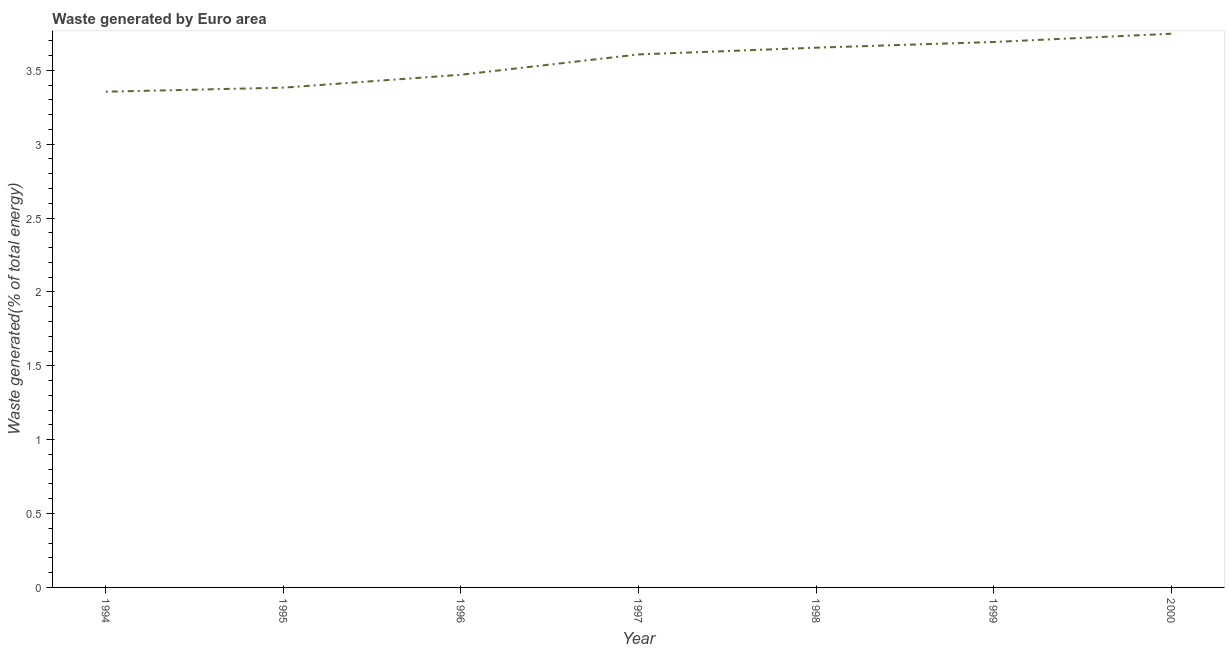What is the amount of waste generated in 2000?
Offer a very short reply. 3.75. Across all years, what is the maximum amount of waste generated?
Your answer should be compact. 3.75. Across all years, what is the minimum amount of waste generated?
Provide a succinct answer. 3.35. What is the sum of the amount of waste generated?
Give a very brief answer. 24.91. What is the difference between the amount of waste generated in 1994 and 1997?
Give a very brief answer. -0.25. What is the average amount of waste generated per year?
Your answer should be very brief. 3.56. What is the median amount of waste generated?
Your response must be concise. 3.61. What is the ratio of the amount of waste generated in 1994 to that in 1997?
Your response must be concise. 0.93. Is the amount of waste generated in 1994 less than that in 1998?
Provide a succinct answer. Yes. Is the difference between the amount of waste generated in 1995 and 2000 greater than the difference between any two years?
Your answer should be very brief. No. What is the difference between the highest and the second highest amount of waste generated?
Provide a short and direct response. 0.06. Is the sum of the amount of waste generated in 1994 and 1995 greater than the maximum amount of waste generated across all years?
Make the answer very short. Yes. What is the difference between the highest and the lowest amount of waste generated?
Offer a terse response. 0.39. How many years are there in the graph?
Give a very brief answer. 7. What is the difference between two consecutive major ticks on the Y-axis?
Ensure brevity in your answer.  0.5. What is the title of the graph?
Offer a very short reply. Waste generated by Euro area. What is the label or title of the Y-axis?
Offer a very short reply. Waste generated(% of total energy). What is the Waste generated(% of total energy) of 1994?
Your answer should be compact. 3.35. What is the Waste generated(% of total energy) in 1995?
Provide a succinct answer. 3.38. What is the Waste generated(% of total energy) in 1996?
Offer a terse response. 3.47. What is the Waste generated(% of total energy) of 1997?
Give a very brief answer. 3.61. What is the Waste generated(% of total energy) in 1998?
Give a very brief answer. 3.65. What is the Waste generated(% of total energy) of 1999?
Ensure brevity in your answer.  3.69. What is the Waste generated(% of total energy) in 2000?
Keep it short and to the point. 3.75. What is the difference between the Waste generated(% of total energy) in 1994 and 1995?
Provide a succinct answer. -0.03. What is the difference between the Waste generated(% of total energy) in 1994 and 1996?
Offer a very short reply. -0.11. What is the difference between the Waste generated(% of total energy) in 1994 and 1997?
Offer a very short reply. -0.25. What is the difference between the Waste generated(% of total energy) in 1994 and 1998?
Make the answer very short. -0.3. What is the difference between the Waste generated(% of total energy) in 1994 and 1999?
Your answer should be compact. -0.34. What is the difference between the Waste generated(% of total energy) in 1994 and 2000?
Provide a short and direct response. -0.39. What is the difference between the Waste generated(% of total energy) in 1995 and 1996?
Provide a succinct answer. -0.09. What is the difference between the Waste generated(% of total energy) in 1995 and 1997?
Keep it short and to the point. -0.22. What is the difference between the Waste generated(% of total energy) in 1995 and 1998?
Offer a very short reply. -0.27. What is the difference between the Waste generated(% of total energy) in 1995 and 1999?
Provide a succinct answer. -0.31. What is the difference between the Waste generated(% of total energy) in 1995 and 2000?
Make the answer very short. -0.36. What is the difference between the Waste generated(% of total energy) in 1996 and 1997?
Provide a succinct answer. -0.14. What is the difference between the Waste generated(% of total energy) in 1996 and 1998?
Give a very brief answer. -0.18. What is the difference between the Waste generated(% of total energy) in 1996 and 1999?
Your response must be concise. -0.22. What is the difference between the Waste generated(% of total energy) in 1996 and 2000?
Your response must be concise. -0.28. What is the difference between the Waste generated(% of total energy) in 1997 and 1998?
Provide a succinct answer. -0.05. What is the difference between the Waste generated(% of total energy) in 1997 and 1999?
Your answer should be very brief. -0.08. What is the difference between the Waste generated(% of total energy) in 1997 and 2000?
Offer a very short reply. -0.14. What is the difference between the Waste generated(% of total energy) in 1998 and 1999?
Provide a succinct answer. -0.04. What is the difference between the Waste generated(% of total energy) in 1998 and 2000?
Offer a terse response. -0.09. What is the difference between the Waste generated(% of total energy) in 1999 and 2000?
Your answer should be compact. -0.06. What is the ratio of the Waste generated(% of total energy) in 1994 to that in 1997?
Provide a short and direct response. 0.93. What is the ratio of the Waste generated(% of total energy) in 1994 to that in 1998?
Offer a very short reply. 0.92. What is the ratio of the Waste generated(% of total energy) in 1994 to that in 1999?
Keep it short and to the point. 0.91. What is the ratio of the Waste generated(% of total energy) in 1994 to that in 2000?
Keep it short and to the point. 0.9. What is the ratio of the Waste generated(% of total energy) in 1995 to that in 1996?
Provide a short and direct response. 0.97. What is the ratio of the Waste generated(% of total energy) in 1995 to that in 1997?
Make the answer very short. 0.94. What is the ratio of the Waste generated(% of total energy) in 1995 to that in 1998?
Make the answer very short. 0.93. What is the ratio of the Waste generated(% of total energy) in 1995 to that in 1999?
Ensure brevity in your answer.  0.92. What is the ratio of the Waste generated(% of total energy) in 1995 to that in 2000?
Make the answer very short. 0.9. What is the ratio of the Waste generated(% of total energy) in 1996 to that in 1997?
Keep it short and to the point. 0.96. What is the ratio of the Waste generated(% of total energy) in 1996 to that in 1998?
Provide a short and direct response. 0.95. What is the ratio of the Waste generated(% of total energy) in 1996 to that in 1999?
Give a very brief answer. 0.94. What is the ratio of the Waste generated(% of total energy) in 1996 to that in 2000?
Provide a short and direct response. 0.93. What is the ratio of the Waste generated(% of total energy) in 1997 to that in 1999?
Keep it short and to the point. 0.98. What is the ratio of the Waste generated(% of total energy) in 1998 to that in 2000?
Your answer should be compact. 0.97. What is the ratio of the Waste generated(% of total energy) in 1999 to that in 2000?
Your answer should be compact. 0.98. 